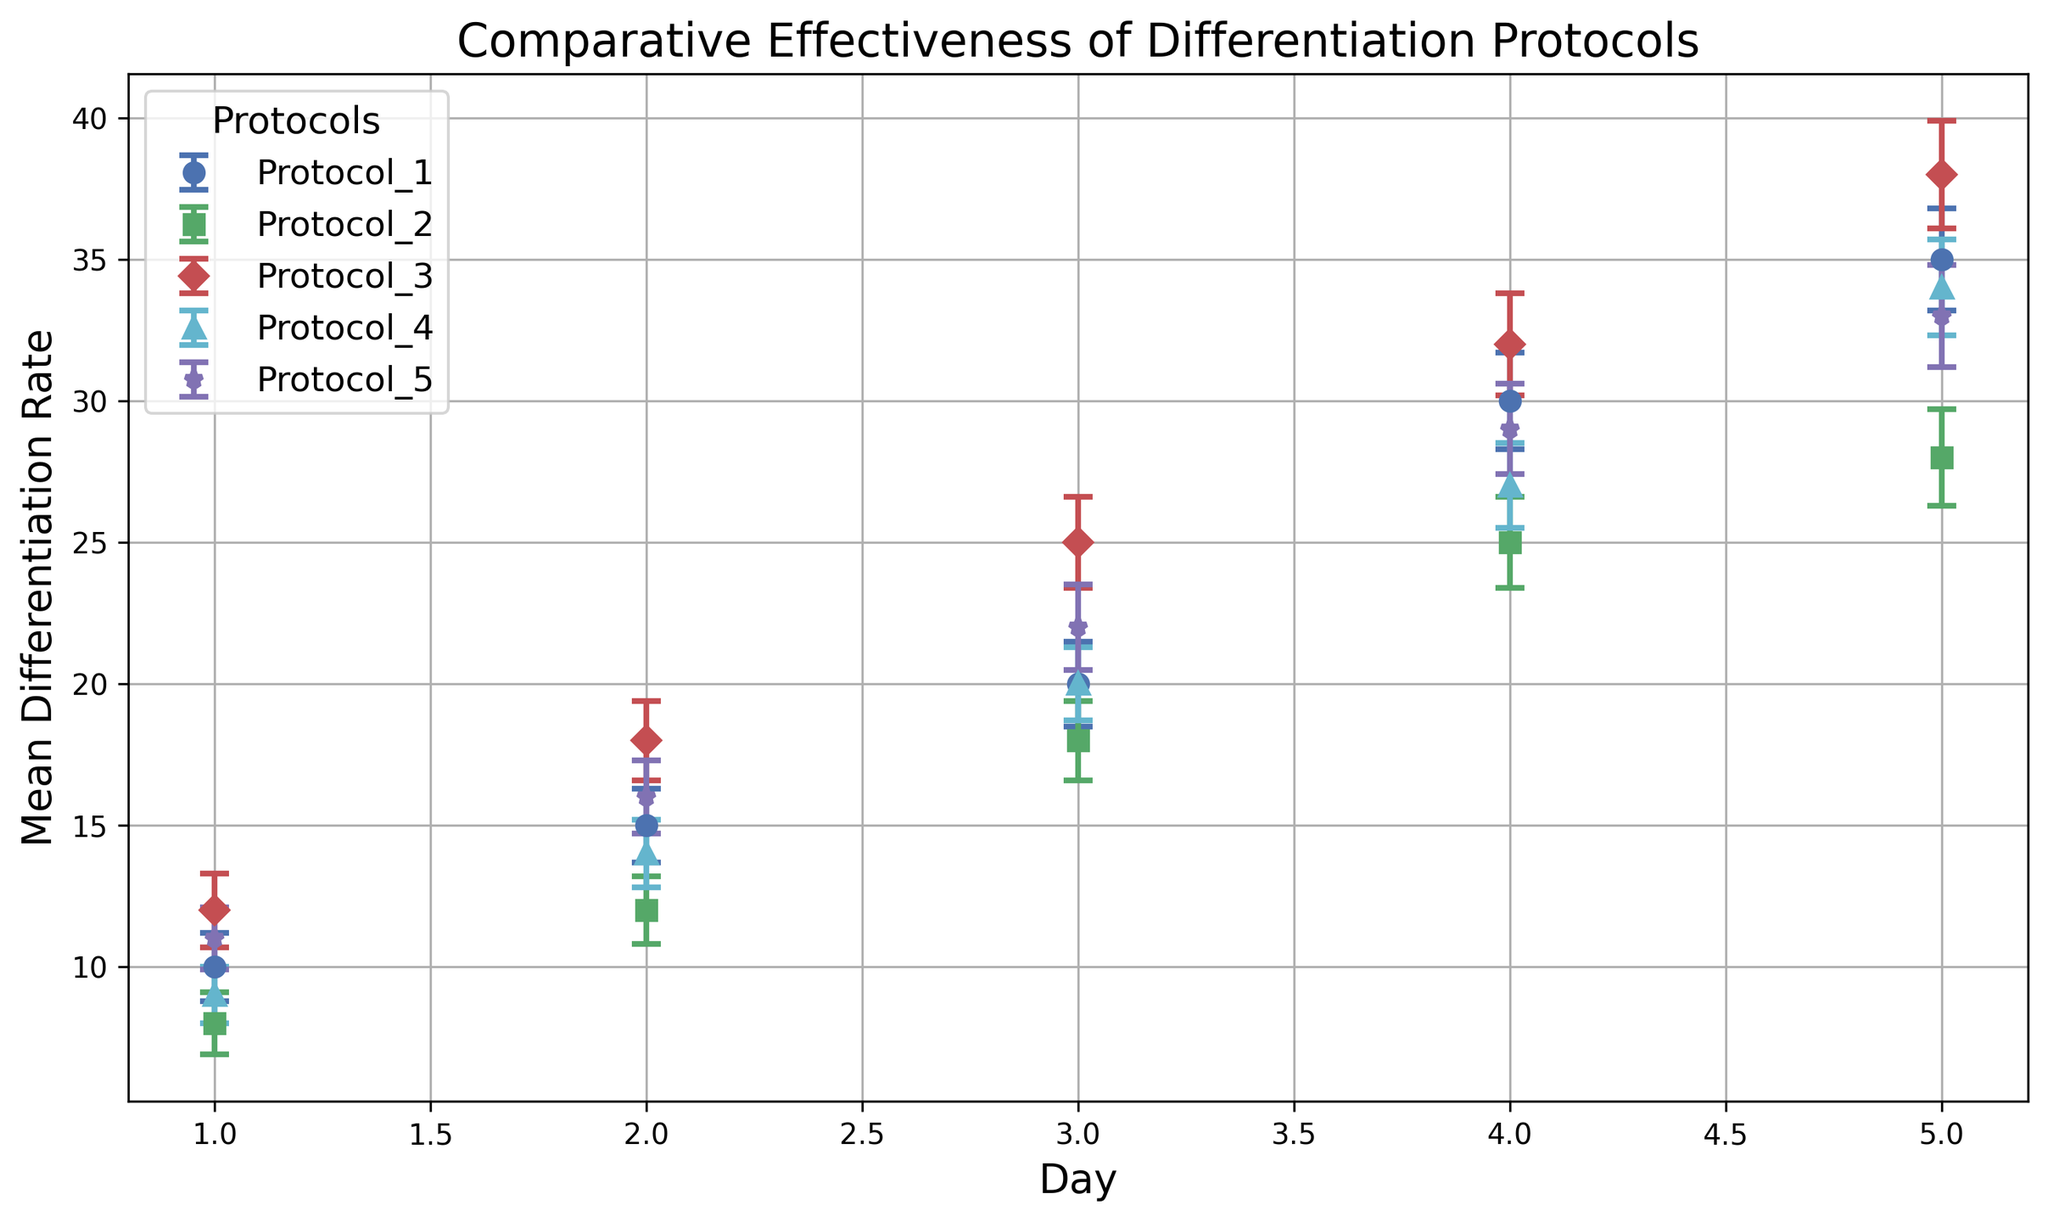Which protocol achieved the highest mean differentiation rate on day 5? Look at the data points for day 5 and compare the mean differentiation rates for all protocols. Protocol_3 has a mean differentiation rate of 38, which is the highest among all.
Answer: Protocol_3 How does the mean differentiation rate for Protocol_1 on day 2 compare to Protocol_4 on the same day? Locate the data points for both Protocol_1 and Protocol_4 on day 2. Protocol_1 has a mean differentiation rate of 15, while Protocol_4 has 14. Comparing these, Protocol_1 has a higher rate.
Answer: Protocol_1 is higher Which day shows the largest variability in mean differentiation rate for Protocol_3 based on error bars? Examine the lengths of the error bars for Protocol_3 across all days. The longest error bar, indicating the largest variability, appears on day 5 with a standard deviation of 1.9.
Answer: Day 5 Is the differentiation rate for Protocol_2 on day 4 closer to the rate of Protocol_5 on day 3 or Protocol_1 on day 3? Compare Protocol_2's rate on day 4 (25) with Protocol_5 on day 3 (22) and Protocol_1 on day 3 (20). 25 is closer to 22 than 20.
Answer: Protocol_5 on day 3 Which protocol exhibits the smallest increase in mean differentiation rate from day 1 to day 5? Calculate the increase from day 1 to day 5 for each protocol: 
- Protocol_1: 35 - 10 = 25 
- Protocol_2: 28 - 8 = 20 
- Protocol_3: 38 - 12 = 26 
- Protocol_4: 34 - 9 = 25 
- Protocol_5: 33 - 11 = 22
Protocol_2 has the smallest increase of 20.
Answer: Protocol_2 What is the average mean differentiation rate for Protocol_5 across all 5 days? Sum the mean differentiation rates for all 5 days in Protocol_5: (11 + 16 + 22 + 29 + 33) = 111, and divide by the number of days (5). The average is 111 / 5 = 22.2.
Answer: 22.2 Between Protocol_2 and Protocol_3, which has a higher mean differentiation rate on day 4? Compare the mean differentiation rates on day 4 for both protocols. Protocol_2 has 25, and Protocol_3 has 32. Protocol_3 has a higher rate.
Answer: Protocol_3 What's the difference in mean differentiation rate between Protocol_1 and Protocol_3 on day 5? Subtract the mean differentiation rate of Protocol_1 from Protocol_3 on day 5. Protocol_3 has 38 and Protocol_1 has 35. The difference is 38 - 35 = 3.
Answer: 3 